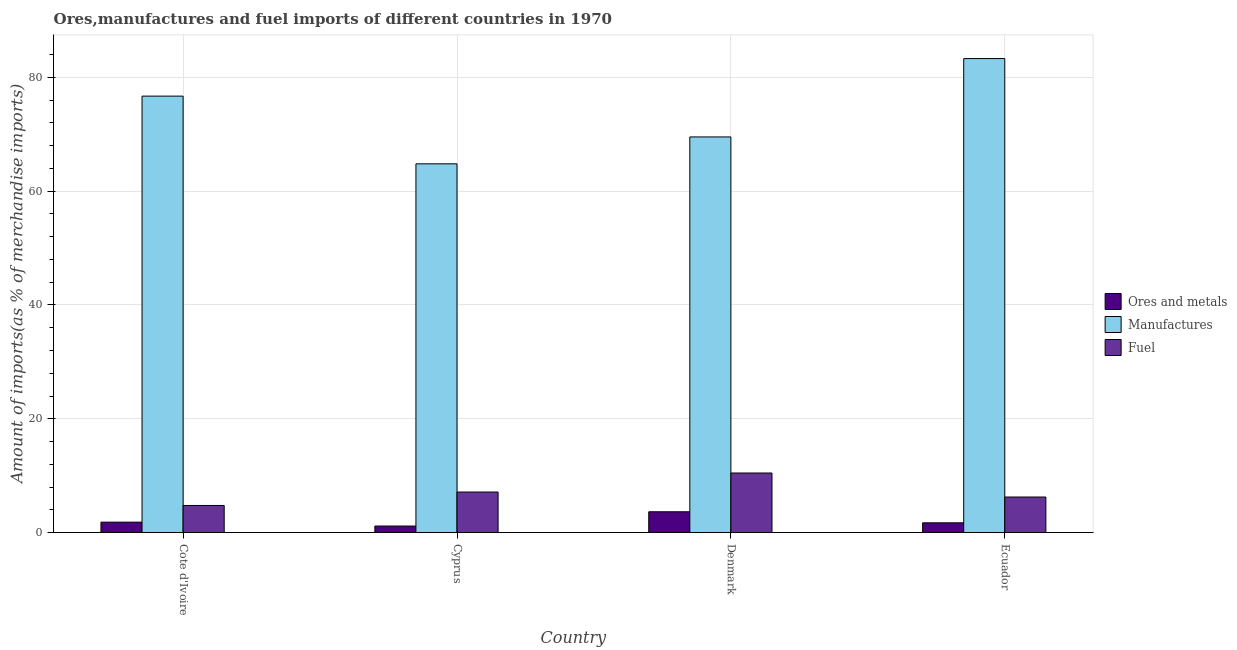How many different coloured bars are there?
Keep it short and to the point. 3. Are the number of bars per tick equal to the number of legend labels?
Your answer should be very brief. Yes. What is the label of the 1st group of bars from the left?
Ensure brevity in your answer.  Cote d'Ivoire. In how many cases, is the number of bars for a given country not equal to the number of legend labels?
Offer a terse response. 0. What is the percentage of ores and metals imports in Ecuador?
Ensure brevity in your answer.  1.72. Across all countries, what is the maximum percentage of manufactures imports?
Your answer should be compact. 83.3. Across all countries, what is the minimum percentage of fuel imports?
Your answer should be very brief. 4.76. In which country was the percentage of ores and metals imports maximum?
Your response must be concise. Denmark. In which country was the percentage of fuel imports minimum?
Ensure brevity in your answer.  Cote d'Ivoire. What is the total percentage of fuel imports in the graph?
Provide a succinct answer. 28.61. What is the difference between the percentage of ores and metals imports in Cote d'Ivoire and that in Cyprus?
Keep it short and to the point. 0.68. What is the difference between the percentage of fuel imports in Denmark and the percentage of manufactures imports in Cyprus?
Provide a short and direct response. -54.33. What is the average percentage of fuel imports per country?
Provide a short and direct response. 7.15. What is the difference between the percentage of manufactures imports and percentage of ores and metals imports in Cyprus?
Your answer should be compact. 63.65. In how many countries, is the percentage of manufactures imports greater than 36 %?
Make the answer very short. 4. What is the ratio of the percentage of ores and metals imports in Cote d'Ivoire to that in Denmark?
Ensure brevity in your answer.  0.5. Is the percentage of fuel imports in Denmark less than that in Ecuador?
Make the answer very short. No. What is the difference between the highest and the second highest percentage of fuel imports?
Keep it short and to the point. 3.35. What is the difference between the highest and the lowest percentage of ores and metals imports?
Give a very brief answer. 2.51. In how many countries, is the percentage of fuel imports greater than the average percentage of fuel imports taken over all countries?
Offer a terse response. 1. What does the 1st bar from the left in Denmark represents?
Your answer should be very brief. Ores and metals. What does the 3rd bar from the right in Cyprus represents?
Offer a terse response. Ores and metals. Is it the case that in every country, the sum of the percentage of ores and metals imports and percentage of manufactures imports is greater than the percentage of fuel imports?
Provide a succinct answer. Yes. How many bars are there?
Provide a short and direct response. 12. What is the difference between two consecutive major ticks on the Y-axis?
Give a very brief answer. 20. How many legend labels are there?
Give a very brief answer. 3. What is the title of the graph?
Your answer should be very brief. Ores,manufactures and fuel imports of different countries in 1970. What is the label or title of the X-axis?
Keep it short and to the point. Country. What is the label or title of the Y-axis?
Your response must be concise. Amount of imports(as % of merchandise imports). What is the Amount of imports(as % of merchandise imports) of Ores and metals in Cote d'Ivoire?
Give a very brief answer. 1.83. What is the Amount of imports(as % of merchandise imports) of Manufactures in Cote d'Ivoire?
Keep it short and to the point. 76.7. What is the Amount of imports(as % of merchandise imports) of Fuel in Cote d'Ivoire?
Your answer should be compact. 4.76. What is the Amount of imports(as % of merchandise imports) of Ores and metals in Cyprus?
Provide a short and direct response. 1.15. What is the Amount of imports(as % of merchandise imports) in Manufactures in Cyprus?
Provide a succinct answer. 64.8. What is the Amount of imports(as % of merchandise imports) in Fuel in Cyprus?
Your response must be concise. 7.13. What is the Amount of imports(as % of merchandise imports) in Ores and metals in Denmark?
Your answer should be compact. 3.66. What is the Amount of imports(as % of merchandise imports) in Manufactures in Denmark?
Your answer should be compact. 69.53. What is the Amount of imports(as % of merchandise imports) in Fuel in Denmark?
Your answer should be compact. 10.47. What is the Amount of imports(as % of merchandise imports) in Ores and metals in Ecuador?
Make the answer very short. 1.72. What is the Amount of imports(as % of merchandise imports) of Manufactures in Ecuador?
Keep it short and to the point. 83.3. What is the Amount of imports(as % of merchandise imports) in Fuel in Ecuador?
Make the answer very short. 6.25. Across all countries, what is the maximum Amount of imports(as % of merchandise imports) of Ores and metals?
Offer a very short reply. 3.66. Across all countries, what is the maximum Amount of imports(as % of merchandise imports) in Manufactures?
Your response must be concise. 83.3. Across all countries, what is the maximum Amount of imports(as % of merchandise imports) in Fuel?
Offer a terse response. 10.47. Across all countries, what is the minimum Amount of imports(as % of merchandise imports) in Ores and metals?
Your answer should be compact. 1.15. Across all countries, what is the minimum Amount of imports(as % of merchandise imports) of Manufactures?
Offer a very short reply. 64.8. Across all countries, what is the minimum Amount of imports(as % of merchandise imports) of Fuel?
Make the answer very short. 4.76. What is the total Amount of imports(as % of merchandise imports) of Ores and metals in the graph?
Provide a succinct answer. 8.36. What is the total Amount of imports(as % of merchandise imports) in Manufactures in the graph?
Ensure brevity in your answer.  294.34. What is the total Amount of imports(as % of merchandise imports) in Fuel in the graph?
Your response must be concise. 28.61. What is the difference between the Amount of imports(as % of merchandise imports) of Ores and metals in Cote d'Ivoire and that in Cyprus?
Keep it short and to the point. 0.68. What is the difference between the Amount of imports(as % of merchandise imports) of Manufactures in Cote d'Ivoire and that in Cyprus?
Your answer should be very brief. 11.9. What is the difference between the Amount of imports(as % of merchandise imports) of Fuel in Cote d'Ivoire and that in Cyprus?
Provide a succinct answer. -2.36. What is the difference between the Amount of imports(as % of merchandise imports) of Ores and metals in Cote d'Ivoire and that in Denmark?
Give a very brief answer. -1.82. What is the difference between the Amount of imports(as % of merchandise imports) in Manufactures in Cote d'Ivoire and that in Denmark?
Provide a short and direct response. 7.17. What is the difference between the Amount of imports(as % of merchandise imports) of Fuel in Cote d'Ivoire and that in Denmark?
Provide a succinct answer. -5.71. What is the difference between the Amount of imports(as % of merchandise imports) in Ores and metals in Cote d'Ivoire and that in Ecuador?
Offer a terse response. 0.12. What is the difference between the Amount of imports(as % of merchandise imports) in Manufactures in Cote d'Ivoire and that in Ecuador?
Ensure brevity in your answer.  -6.6. What is the difference between the Amount of imports(as % of merchandise imports) of Fuel in Cote d'Ivoire and that in Ecuador?
Ensure brevity in your answer.  -1.49. What is the difference between the Amount of imports(as % of merchandise imports) in Ores and metals in Cyprus and that in Denmark?
Your response must be concise. -2.51. What is the difference between the Amount of imports(as % of merchandise imports) of Manufactures in Cyprus and that in Denmark?
Your answer should be very brief. -4.73. What is the difference between the Amount of imports(as % of merchandise imports) in Fuel in Cyprus and that in Denmark?
Provide a succinct answer. -3.35. What is the difference between the Amount of imports(as % of merchandise imports) of Ores and metals in Cyprus and that in Ecuador?
Provide a succinct answer. -0.57. What is the difference between the Amount of imports(as % of merchandise imports) in Manufactures in Cyprus and that in Ecuador?
Your answer should be compact. -18.5. What is the difference between the Amount of imports(as % of merchandise imports) of Fuel in Cyprus and that in Ecuador?
Make the answer very short. 0.87. What is the difference between the Amount of imports(as % of merchandise imports) of Ores and metals in Denmark and that in Ecuador?
Ensure brevity in your answer.  1.94. What is the difference between the Amount of imports(as % of merchandise imports) of Manufactures in Denmark and that in Ecuador?
Offer a terse response. -13.77. What is the difference between the Amount of imports(as % of merchandise imports) in Fuel in Denmark and that in Ecuador?
Provide a succinct answer. 4.22. What is the difference between the Amount of imports(as % of merchandise imports) of Ores and metals in Cote d'Ivoire and the Amount of imports(as % of merchandise imports) of Manufactures in Cyprus?
Make the answer very short. -62.97. What is the difference between the Amount of imports(as % of merchandise imports) of Ores and metals in Cote d'Ivoire and the Amount of imports(as % of merchandise imports) of Fuel in Cyprus?
Keep it short and to the point. -5.29. What is the difference between the Amount of imports(as % of merchandise imports) in Manufactures in Cote d'Ivoire and the Amount of imports(as % of merchandise imports) in Fuel in Cyprus?
Provide a short and direct response. 69.58. What is the difference between the Amount of imports(as % of merchandise imports) in Ores and metals in Cote d'Ivoire and the Amount of imports(as % of merchandise imports) in Manufactures in Denmark?
Provide a succinct answer. -67.7. What is the difference between the Amount of imports(as % of merchandise imports) of Ores and metals in Cote d'Ivoire and the Amount of imports(as % of merchandise imports) of Fuel in Denmark?
Make the answer very short. -8.64. What is the difference between the Amount of imports(as % of merchandise imports) in Manufactures in Cote d'Ivoire and the Amount of imports(as % of merchandise imports) in Fuel in Denmark?
Offer a very short reply. 66.23. What is the difference between the Amount of imports(as % of merchandise imports) of Ores and metals in Cote d'Ivoire and the Amount of imports(as % of merchandise imports) of Manufactures in Ecuador?
Offer a very short reply. -81.47. What is the difference between the Amount of imports(as % of merchandise imports) of Ores and metals in Cote d'Ivoire and the Amount of imports(as % of merchandise imports) of Fuel in Ecuador?
Make the answer very short. -4.42. What is the difference between the Amount of imports(as % of merchandise imports) of Manufactures in Cote d'Ivoire and the Amount of imports(as % of merchandise imports) of Fuel in Ecuador?
Make the answer very short. 70.45. What is the difference between the Amount of imports(as % of merchandise imports) in Ores and metals in Cyprus and the Amount of imports(as % of merchandise imports) in Manufactures in Denmark?
Your response must be concise. -68.38. What is the difference between the Amount of imports(as % of merchandise imports) of Ores and metals in Cyprus and the Amount of imports(as % of merchandise imports) of Fuel in Denmark?
Ensure brevity in your answer.  -9.32. What is the difference between the Amount of imports(as % of merchandise imports) in Manufactures in Cyprus and the Amount of imports(as % of merchandise imports) in Fuel in Denmark?
Provide a succinct answer. 54.33. What is the difference between the Amount of imports(as % of merchandise imports) of Ores and metals in Cyprus and the Amount of imports(as % of merchandise imports) of Manufactures in Ecuador?
Keep it short and to the point. -82.15. What is the difference between the Amount of imports(as % of merchandise imports) of Ores and metals in Cyprus and the Amount of imports(as % of merchandise imports) of Fuel in Ecuador?
Provide a succinct answer. -5.1. What is the difference between the Amount of imports(as % of merchandise imports) in Manufactures in Cyprus and the Amount of imports(as % of merchandise imports) in Fuel in Ecuador?
Ensure brevity in your answer.  58.55. What is the difference between the Amount of imports(as % of merchandise imports) in Ores and metals in Denmark and the Amount of imports(as % of merchandise imports) in Manufactures in Ecuador?
Provide a succinct answer. -79.64. What is the difference between the Amount of imports(as % of merchandise imports) in Ores and metals in Denmark and the Amount of imports(as % of merchandise imports) in Fuel in Ecuador?
Your answer should be compact. -2.59. What is the difference between the Amount of imports(as % of merchandise imports) of Manufactures in Denmark and the Amount of imports(as % of merchandise imports) of Fuel in Ecuador?
Keep it short and to the point. 63.28. What is the average Amount of imports(as % of merchandise imports) in Ores and metals per country?
Provide a succinct answer. 2.09. What is the average Amount of imports(as % of merchandise imports) in Manufactures per country?
Your response must be concise. 73.59. What is the average Amount of imports(as % of merchandise imports) of Fuel per country?
Make the answer very short. 7.15. What is the difference between the Amount of imports(as % of merchandise imports) in Ores and metals and Amount of imports(as % of merchandise imports) in Manufactures in Cote d'Ivoire?
Offer a terse response. -74.87. What is the difference between the Amount of imports(as % of merchandise imports) in Ores and metals and Amount of imports(as % of merchandise imports) in Fuel in Cote d'Ivoire?
Your answer should be compact. -2.93. What is the difference between the Amount of imports(as % of merchandise imports) in Manufactures and Amount of imports(as % of merchandise imports) in Fuel in Cote d'Ivoire?
Your answer should be very brief. 71.94. What is the difference between the Amount of imports(as % of merchandise imports) in Ores and metals and Amount of imports(as % of merchandise imports) in Manufactures in Cyprus?
Offer a terse response. -63.65. What is the difference between the Amount of imports(as % of merchandise imports) in Ores and metals and Amount of imports(as % of merchandise imports) in Fuel in Cyprus?
Provide a short and direct response. -5.97. What is the difference between the Amount of imports(as % of merchandise imports) of Manufactures and Amount of imports(as % of merchandise imports) of Fuel in Cyprus?
Your response must be concise. 57.68. What is the difference between the Amount of imports(as % of merchandise imports) in Ores and metals and Amount of imports(as % of merchandise imports) in Manufactures in Denmark?
Make the answer very short. -65.87. What is the difference between the Amount of imports(as % of merchandise imports) of Ores and metals and Amount of imports(as % of merchandise imports) of Fuel in Denmark?
Make the answer very short. -6.81. What is the difference between the Amount of imports(as % of merchandise imports) in Manufactures and Amount of imports(as % of merchandise imports) in Fuel in Denmark?
Ensure brevity in your answer.  59.06. What is the difference between the Amount of imports(as % of merchandise imports) in Ores and metals and Amount of imports(as % of merchandise imports) in Manufactures in Ecuador?
Your response must be concise. -81.58. What is the difference between the Amount of imports(as % of merchandise imports) in Ores and metals and Amount of imports(as % of merchandise imports) in Fuel in Ecuador?
Your answer should be very brief. -4.53. What is the difference between the Amount of imports(as % of merchandise imports) of Manufactures and Amount of imports(as % of merchandise imports) of Fuel in Ecuador?
Offer a terse response. 77.05. What is the ratio of the Amount of imports(as % of merchandise imports) of Ores and metals in Cote d'Ivoire to that in Cyprus?
Your response must be concise. 1.59. What is the ratio of the Amount of imports(as % of merchandise imports) of Manufactures in Cote d'Ivoire to that in Cyprus?
Provide a succinct answer. 1.18. What is the ratio of the Amount of imports(as % of merchandise imports) of Fuel in Cote d'Ivoire to that in Cyprus?
Your response must be concise. 0.67. What is the ratio of the Amount of imports(as % of merchandise imports) in Ores and metals in Cote d'Ivoire to that in Denmark?
Give a very brief answer. 0.5. What is the ratio of the Amount of imports(as % of merchandise imports) in Manufactures in Cote d'Ivoire to that in Denmark?
Give a very brief answer. 1.1. What is the ratio of the Amount of imports(as % of merchandise imports) of Fuel in Cote d'Ivoire to that in Denmark?
Your answer should be very brief. 0.46. What is the ratio of the Amount of imports(as % of merchandise imports) in Ores and metals in Cote d'Ivoire to that in Ecuador?
Keep it short and to the point. 1.07. What is the ratio of the Amount of imports(as % of merchandise imports) in Manufactures in Cote d'Ivoire to that in Ecuador?
Ensure brevity in your answer.  0.92. What is the ratio of the Amount of imports(as % of merchandise imports) of Fuel in Cote d'Ivoire to that in Ecuador?
Offer a very short reply. 0.76. What is the ratio of the Amount of imports(as % of merchandise imports) of Ores and metals in Cyprus to that in Denmark?
Your answer should be compact. 0.31. What is the ratio of the Amount of imports(as % of merchandise imports) of Manufactures in Cyprus to that in Denmark?
Offer a terse response. 0.93. What is the ratio of the Amount of imports(as % of merchandise imports) in Fuel in Cyprus to that in Denmark?
Give a very brief answer. 0.68. What is the ratio of the Amount of imports(as % of merchandise imports) of Ores and metals in Cyprus to that in Ecuador?
Your answer should be very brief. 0.67. What is the ratio of the Amount of imports(as % of merchandise imports) of Manufactures in Cyprus to that in Ecuador?
Your answer should be compact. 0.78. What is the ratio of the Amount of imports(as % of merchandise imports) of Fuel in Cyprus to that in Ecuador?
Your answer should be very brief. 1.14. What is the ratio of the Amount of imports(as % of merchandise imports) of Ores and metals in Denmark to that in Ecuador?
Give a very brief answer. 2.13. What is the ratio of the Amount of imports(as % of merchandise imports) in Manufactures in Denmark to that in Ecuador?
Your response must be concise. 0.83. What is the ratio of the Amount of imports(as % of merchandise imports) of Fuel in Denmark to that in Ecuador?
Provide a succinct answer. 1.68. What is the difference between the highest and the second highest Amount of imports(as % of merchandise imports) of Ores and metals?
Your response must be concise. 1.82. What is the difference between the highest and the second highest Amount of imports(as % of merchandise imports) of Manufactures?
Give a very brief answer. 6.6. What is the difference between the highest and the second highest Amount of imports(as % of merchandise imports) of Fuel?
Offer a very short reply. 3.35. What is the difference between the highest and the lowest Amount of imports(as % of merchandise imports) in Ores and metals?
Provide a succinct answer. 2.51. What is the difference between the highest and the lowest Amount of imports(as % of merchandise imports) in Manufactures?
Make the answer very short. 18.5. What is the difference between the highest and the lowest Amount of imports(as % of merchandise imports) of Fuel?
Your answer should be compact. 5.71. 